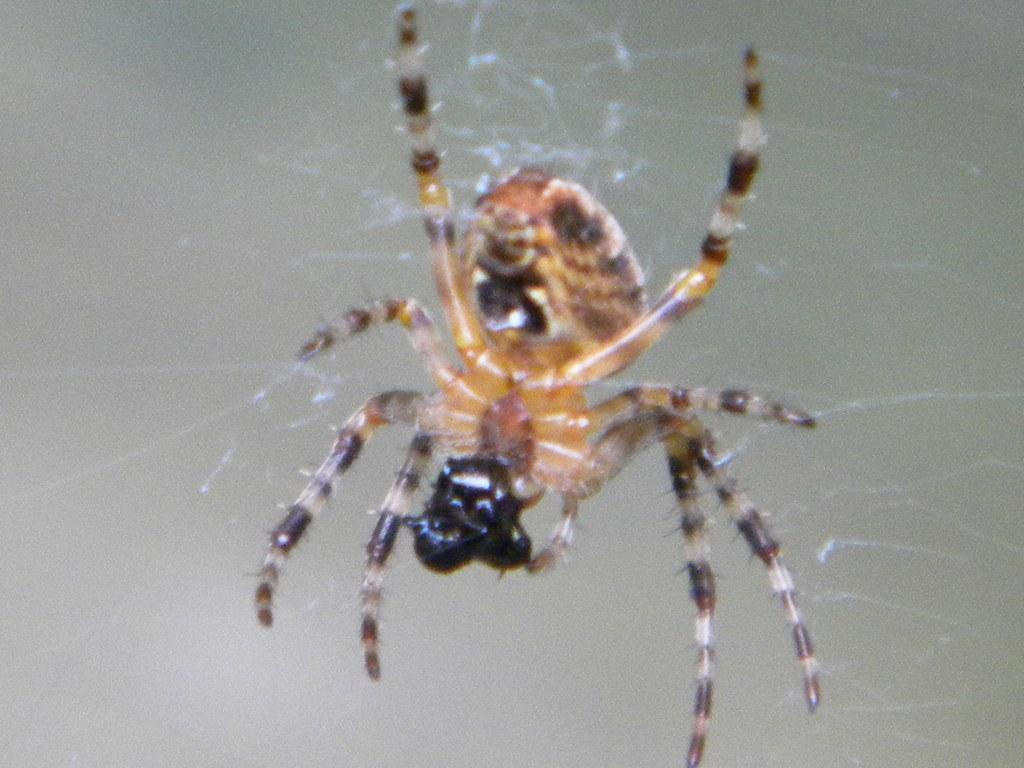What is the main subject of the image? The main subject of the image is a spider. Can you describe the appearance of the spider? The spider is in brown and black color. What else can be seen in the image besides the spider? There is a spider web in the image. What is the color of the background in the image? The background of the image is ash color. How many family members are present in the image? There are no family members present in the image; it features a spider and a spider web. Who is the manager of the spider in the image? There is no manager present in the image, as spiders do not have managers. 